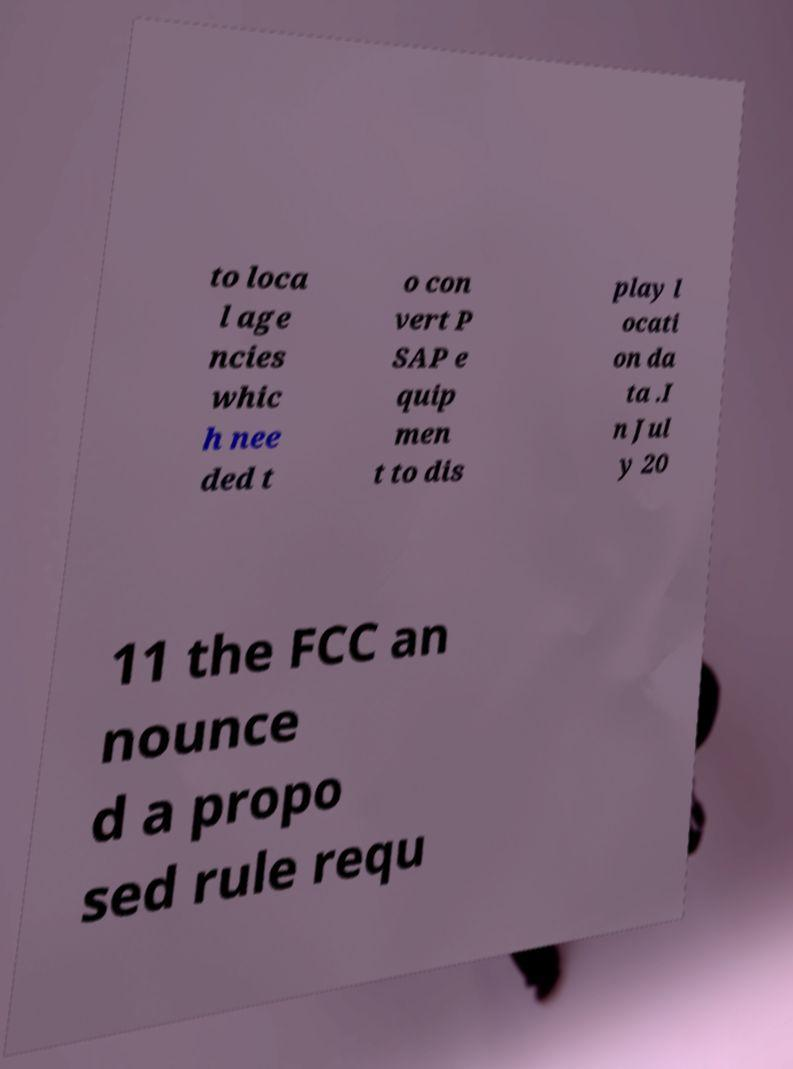Please read and relay the text visible in this image. What does it say? to loca l age ncies whic h nee ded t o con vert P SAP e quip men t to dis play l ocati on da ta .I n Jul y 20 11 the FCC an nounce d a propo sed rule requ 